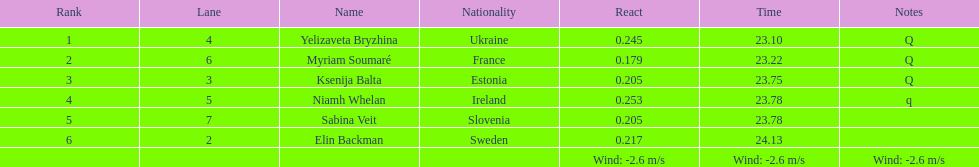Who holds the top rank among players? Yelizaveta Bryzhina. 